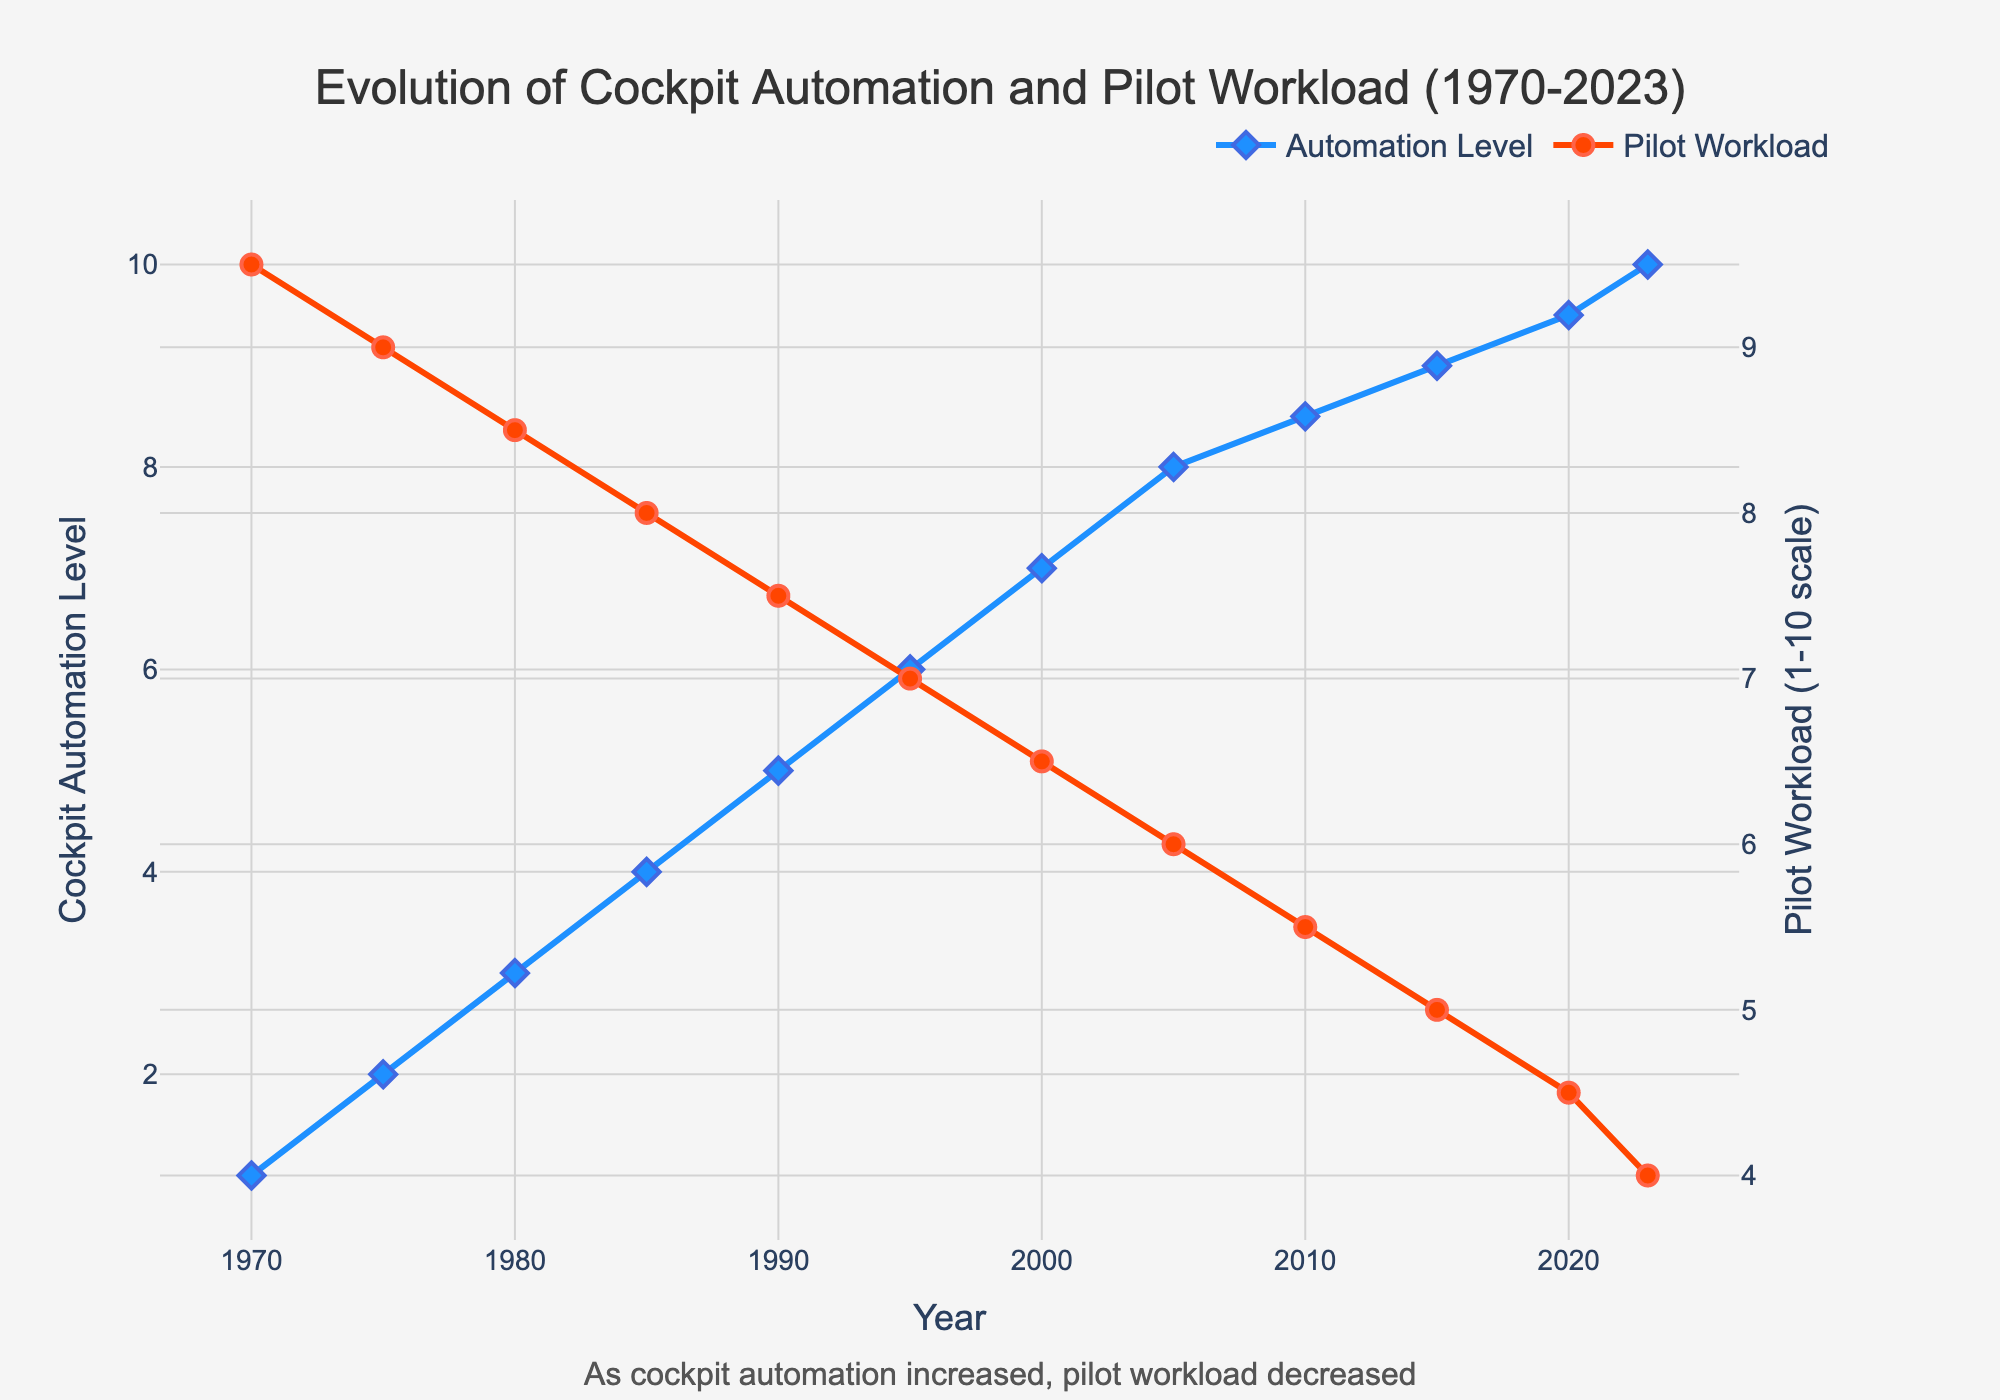What trends do we see in cockpit automation levels and pilot workload from 1970 to 2023? Examining the line chart, we observe that the cockpit automation level steadily increased from 1 in 1970 to 10 in 2023. Conversely, the pilot workload level decreased from 9.5 in 1970 to 4.0 in 2023. This suggests an inverse relationship between automation level and workload.
Answer: Cockpit automation increased, pilot workload decreased What is the largest decrease in pilot workload in any decade? To find this, we look at the difference in pilot workload at the start and end of each decade. The largest decrease happens between 2010 and 2020, where it drops from 5.5 to 4.5, a decrease of 1.0 units.
Answer: 1.0 units How did pilot workload change between 1970 and 1980? We compare the pilot workload values from 1970 and 1980. In 1970, the workload was 9.5, and in 1980 it was 8.5. Therefore, pilot workload decreased by 1.0 units over this period.
Answer: Decreased by 1.0 units When did the cockpit automation level reach 8? We look at the data and find that in 2005, the cockpit automation level is exactly 8.
Answer: 2005 What was the pilot workload when the cockpit automation level was 5? The chart shows that in 1990, the cockpit automation level was 5 and the corresponding pilot workload was 7.5.
Answer: 7.5 Comparing 1985 to 2000, which year had the higher cockpit automation level? By examining the chart, we see that the cockpit automation level in 1985 was 4 and in 2000 it was 7. Thus, 2000 had a higher cockpit automation level.
Answer: 2000 What is the average cockpit automation level from 1990 to 2023? The average is calculated by summing up the automation levels for 1990 (5), 1995 (6), 2000 (7), 2005 (8), 2010 (8.5), 2015 (9), 2020 (9.5), and 2023 (10) and dividing by the number of years. (5 + 6 + 7 + 8 + 8.5 + 9 + 9.5 + 10) / 8 = 7.625.
Answer: 7.625 Which year marks the most significant increase in cockpit automation level? The largest increase is found by comparing the differences between consecutive years. The biggest jump is from 1995 to 2000, where it increased from 6 to 7.
Answer: 1995 to 2000 How does the color representation help in understanding the data in the chart? The cockpit automation levels are shown in blue and pilot workload levels in red. This color differentiation makes it easy to identify and compare the trends for each metric.
Answer: Blue: Automation, Red: Workload 